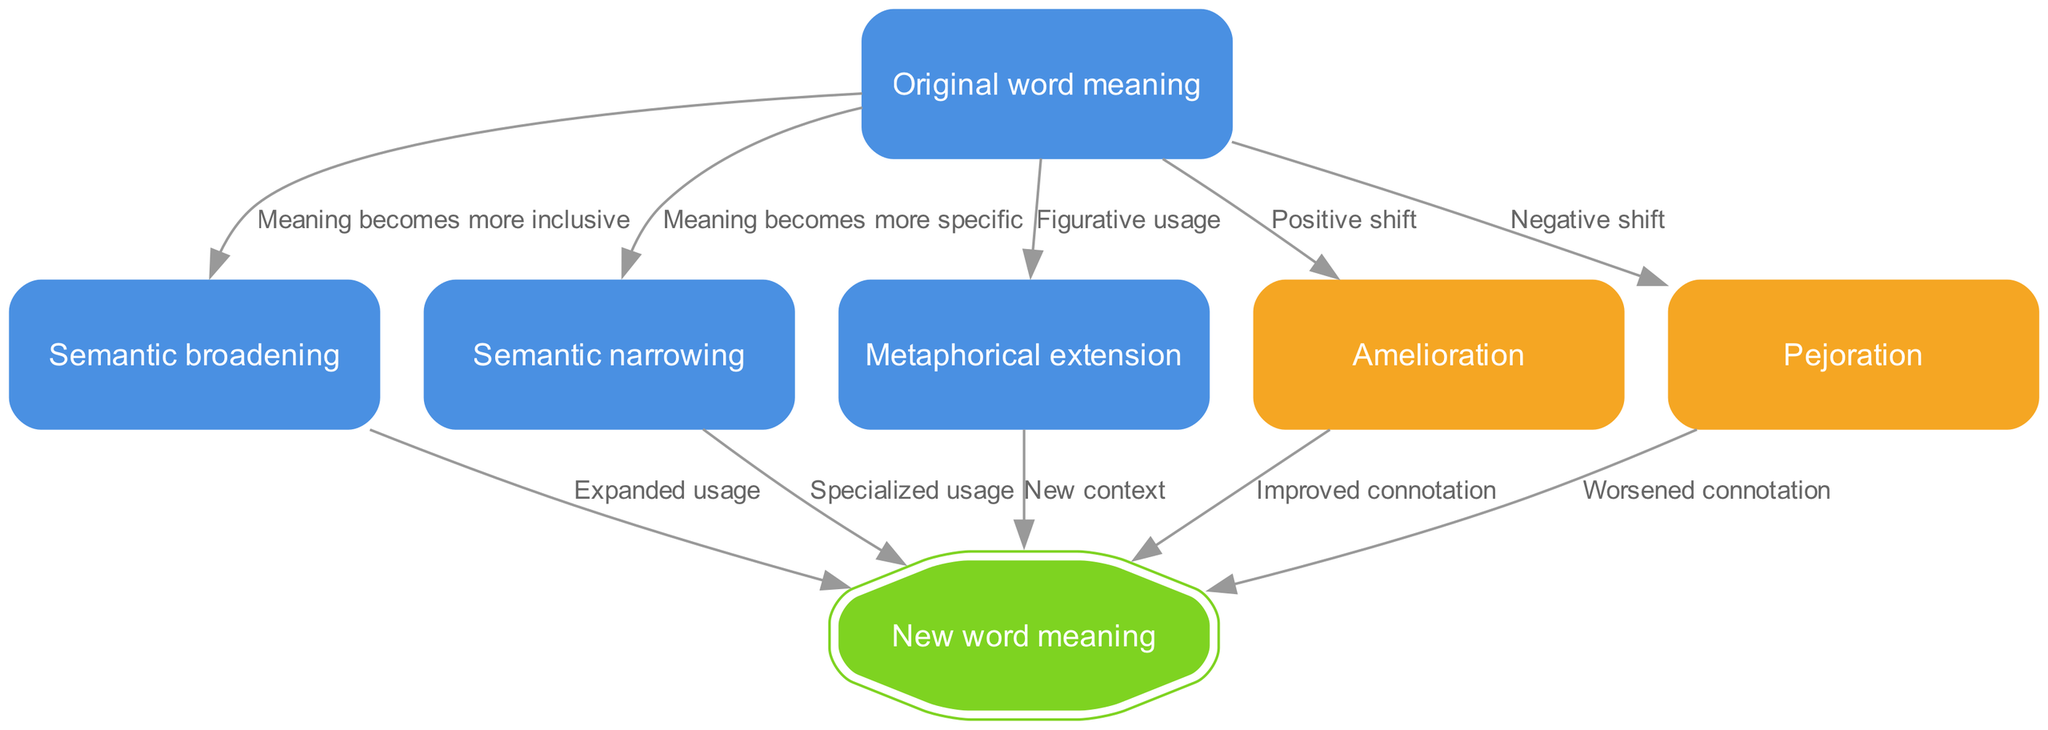What is the starting point of the diagram? The diagram begins with the 'Original word meaning' node, indicating the initial meaning before any semantic changes occur.
Answer: Original word meaning How many nodes are there in the diagram? By counting each distinct node listed in the 'nodes' section of the data, we find there are a total of 6 nodes.
Answer: 6 What does the edge from 'start' to 'semantic broadening' indicate? The edge signifies that the meaning of the original word evolves to become more inclusive, thereby allowing for a broader interpretation of its usage.
Answer: Meaning becomes more inclusive What type of shift does 'amelioration' represent? 'Amelioration' indicates a positive shift in the connotation associated with a word's meaning.
Answer: Positive shift Which nodes lead to 'new word meaning'? The nodes 'semantic broadening', 'semantic narrowing', 'metaphorical extension', 'amelioration', and 'pejoration' all lead to 'new word meaning', indicating various semantic pathways that result in a new interpretation of the word.
Answer: Semantic broadening, semantic narrowing, metaphorical extension, amelioration, pejoration What is the relationship between 'pejoration' and 'new meaning'? The relationship is one of cause and effect, where 'pejoration' specifically results in a worsened connotation as it progresses toward a new meaning for the word.
Answer: Worsened connotation What does the 'metaphorical extension' node signify? This node signifies the process of figurative usage, where the original meaning expands to include metaphorical applications, leading to a new meaning.
Answer: Figurative usage Which node indicates a specialized usage of the original meaning? The 'semantic narrowing' node indicates a specialized usage as it specifies the original meaning instead of broadening it.
Answer: Semantic narrowing What type of diagram is this? This is a flow chart of a function illustrating the evolution of a word's meaning over time, showing different semantic shifts and extensions.
Answer: Flow chart of a function 